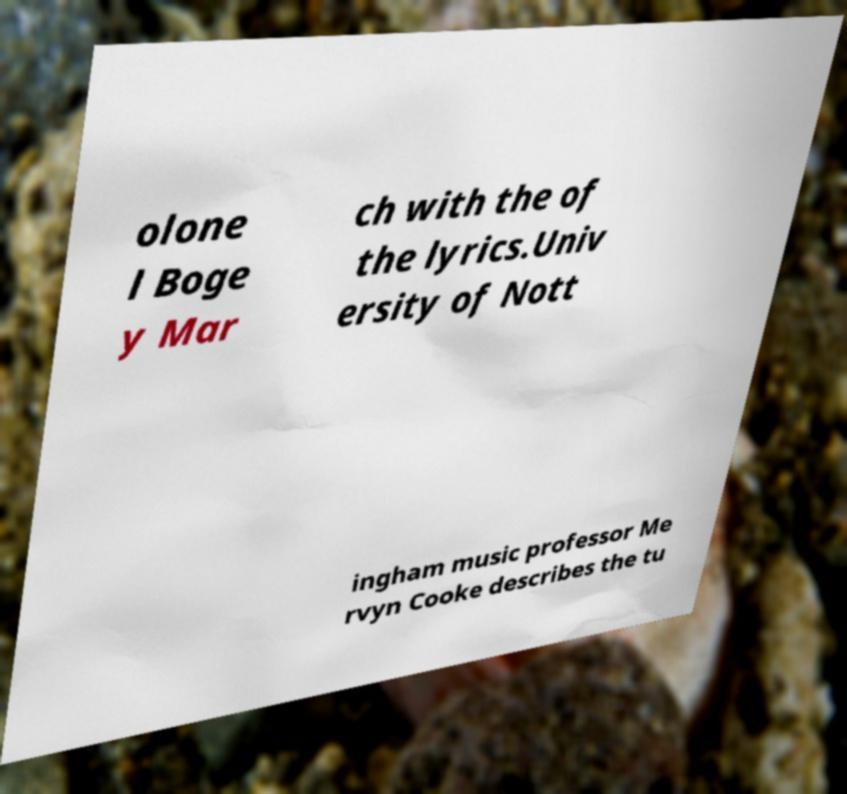There's text embedded in this image that I need extracted. Can you transcribe it verbatim? olone l Boge y Mar ch with the of the lyrics.Univ ersity of Nott ingham music professor Me rvyn Cooke describes the tu 